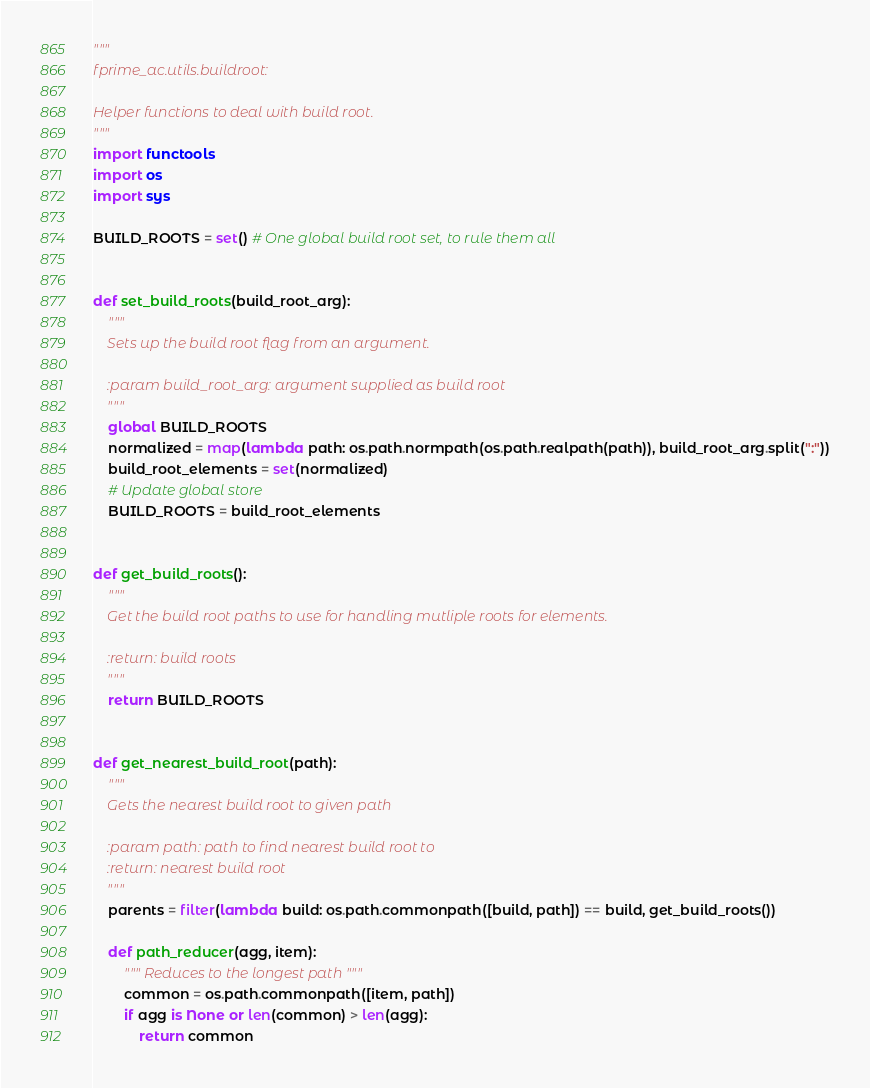<code> <loc_0><loc_0><loc_500><loc_500><_Python_>"""
fprime_ac.utils.buildroot:

Helper functions to deal with build root.
"""
import functools
import os
import sys

BUILD_ROOTS = set() # One global build root set, to rule them all


def set_build_roots(build_root_arg):
    """
    Sets up the build root flag from an argument.

    :param build_root_arg: argument supplied as build root
    """
    global BUILD_ROOTS
    normalized = map(lambda path: os.path.normpath(os.path.realpath(path)), build_root_arg.split(":"))
    build_root_elements = set(normalized)
    # Update global store
    BUILD_ROOTS = build_root_elements


def get_build_roots():
    """
    Get the build root paths to use for handling mutliple roots for elements.

    :return: build roots
    """
    return BUILD_ROOTS


def get_nearest_build_root(path):
    """
    Gets the nearest build root to given path

    :param path: path to find nearest build root to
    :return: nearest build root
    """
    parents = filter(lambda build: os.path.commonpath([build, path]) == build, get_build_roots())

    def path_reducer(agg, item):
        """ Reduces to the longest path """
        common = os.path.commonpath([item, path])
        if agg is None or len(common) > len(agg):
            return common</code> 